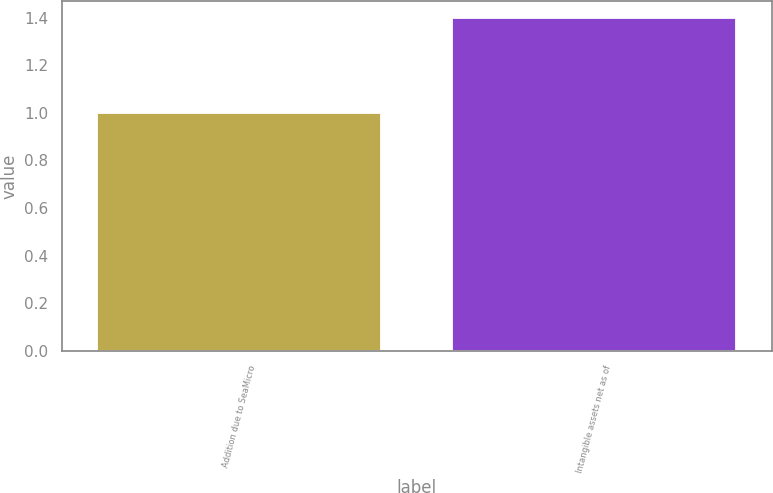Convert chart to OTSL. <chart><loc_0><loc_0><loc_500><loc_500><bar_chart><fcel>Addition due to SeaMicro<fcel>Intangible assets net as of<nl><fcel>1<fcel>1.4<nl></chart> 